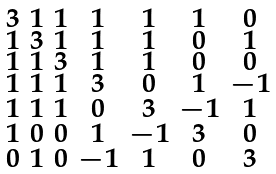<formula> <loc_0><loc_0><loc_500><loc_500>\begin{smallmatrix} 3 & 1 & 1 & 1 & 1 & 1 & 0 \\ 1 & 3 & 1 & 1 & 1 & 0 & 1 \\ 1 & 1 & 3 & 1 & 1 & 0 & 0 \\ 1 & 1 & 1 & 3 & 0 & 1 & - 1 \\ 1 & 1 & 1 & 0 & 3 & - 1 & 1 \\ 1 & 0 & 0 & 1 & - 1 & 3 & 0 \\ 0 & 1 & 0 & - 1 & 1 & 0 & 3 \end{smallmatrix}</formula> 